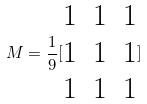Convert formula to latex. <formula><loc_0><loc_0><loc_500><loc_500>M = \frac { 1 } { 9 } [ \begin{matrix} 1 & 1 & 1 \\ 1 & 1 & 1 \\ 1 & 1 & 1 \\ \end{matrix} ]</formula> 